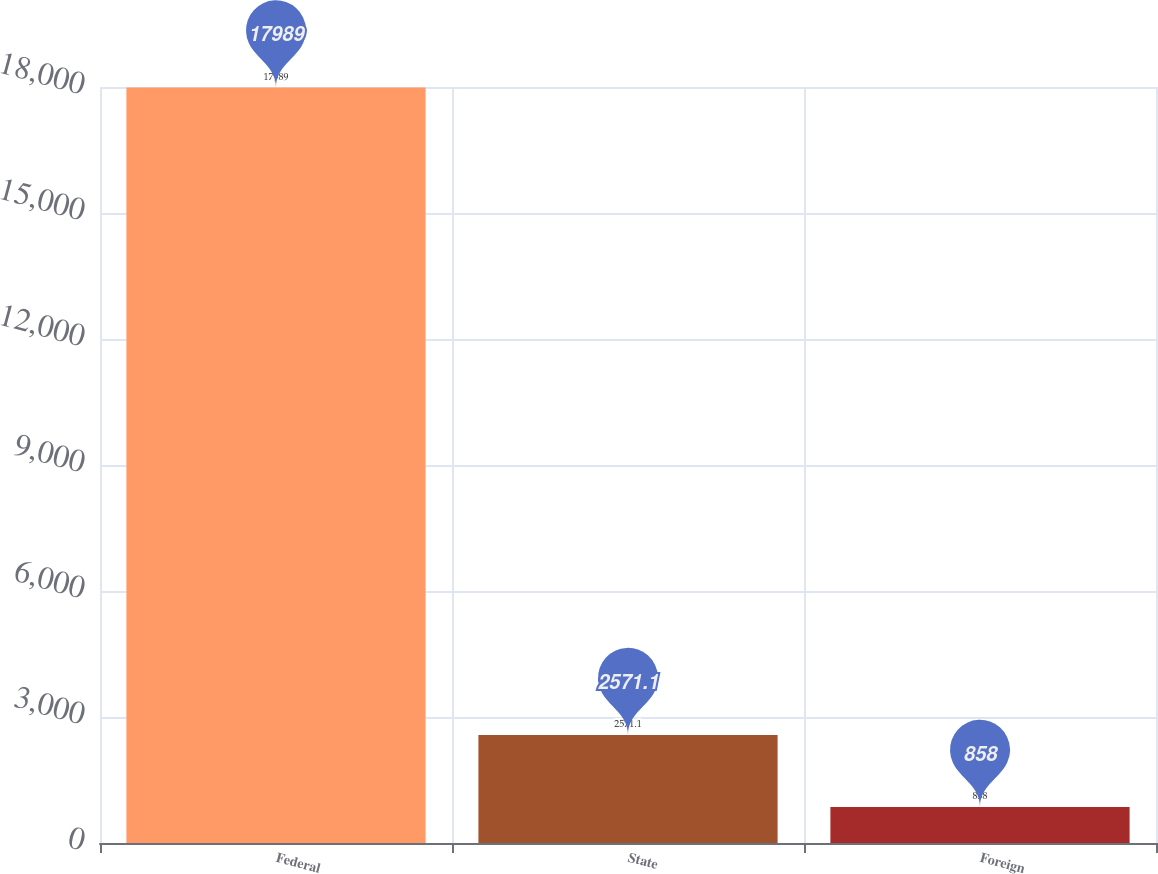Convert chart. <chart><loc_0><loc_0><loc_500><loc_500><bar_chart><fcel>Federal<fcel>State<fcel>Foreign<nl><fcel>17989<fcel>2571.1<fcel>858<nl></chart> 